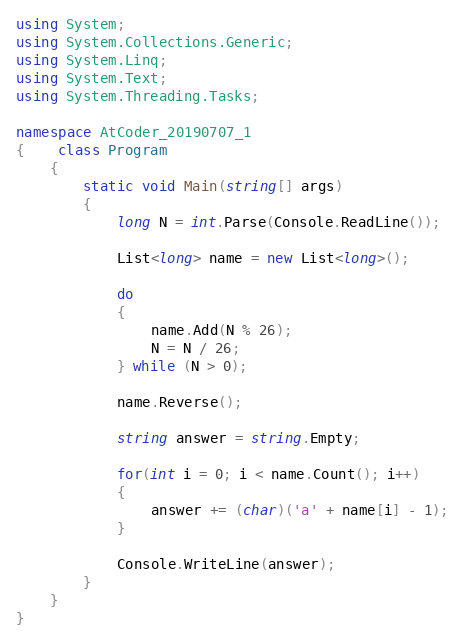Convert code to text. <code><loc_0><loc_0><loc_500><loc_500><_C#_>using System;
using System.Collections.Generic;
using System.Linq;
using System.Text;
using System.Threading.Tasks;

namespace AtCoder_20190707_1
{    class Program
    {
        static void Main(string[] args)
        {
            long N = int.Parse(Console.ReadLine());

            List<long> name = new List<long>();

            do
            {
                name.Add(N % 26);
                N = N / 26;
            } while (N > 0);

            name.Reverse();

            string answer = string.Empty;

            for(int i = 0; i < name.Count(); i++)
            {
                answer += (char)('a' + name[i] - 1);
            }

            Console.WriteLine(answer);
        }
    }
}</code> 